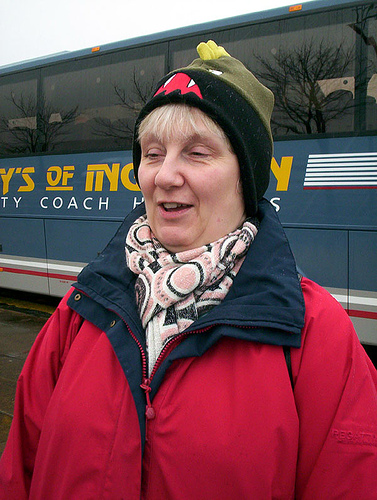<image>What sporting equipment is next to the lady? It is ambiguous what sporting equipment is next to the lady. There may not be any. What sporting equipment is next to the lady? It is impossible to determine what sporting equipment is next to the lady as there is none visible in the image. 